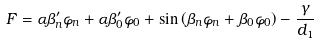<formula> <loc_0><loc_0><loc_500><loc_500>F = \alpha \beta _ { n } ^ { \prime } \varphi _ { n } + \alpha \beta _ { 0 } ^ { \prime } \varphi _ { 0 } + \sin \left ( \beta _ { n } \varphi _ { n } + \beta _ { 0 } \varphi _ { 0 } \right ) - \frac { \gamma } { d _ { 1 } }</formula> 